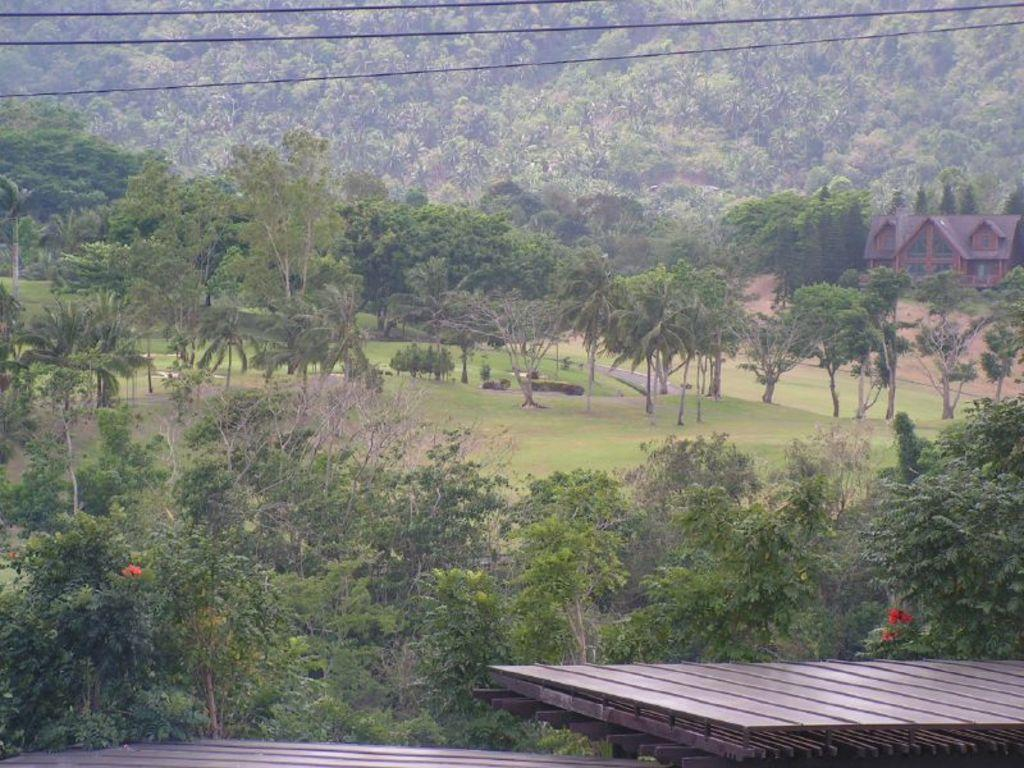What type of structures are visible in the image? There are wooden platforms in the image. What type of vegetation is present in the image? There are trees in the image. What type of building can be seen in the image? There is a house in the image. What type of ground cover is visible in the image? There is grass in the image. What type of utility infrastructure is present in the image? Cables are present in the image. What type of alarm is ringing in the image? There is no alarm present in the image. What type of religious symbol can be seen in the image? There is no religious symbol present in the image. 